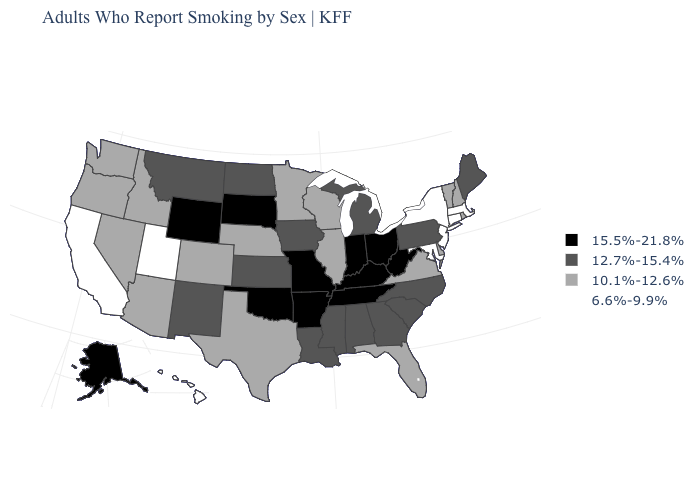Among the states that border Delaware , which have the lowest value?
Give a very brief answer. Maryland, New Jersey. What is the value of New York?
Quick response, please. 6.6%-9.9%. Among the states that border Tennessee , which have the lowest value?
Give a very brief answer. Virginia. Among the states that border South Dakota , which have the highest value?
Be succinct. Wyoming. Among the states that border Minnesota , does South Dakota have the highest value?
Keep it brief. Yes. What is the value of Oregon?
Keep it brief. 10.1%-12.6%. What is the lowest value in states that border New Jersey?
Be succinct. 6.6%-9.9%. Which states have the highest value in the USA?
Concise answer only. Alaska, Arkansas, Indiana, Kentucky, Missouri, Ohio, Oklahoma, South Dakota, Tennessee, West Virginia, Wyoming. Name the states that have a value in the range 10.1%-12.6%?
Short answer required. Arizona, Colorado, Delaware, Florida, Idaho, Illinois, Minnesota, Nebraska, Nevada, New Hampshire, Oregon, Rhode Island, Texas, Vermont, Virginia, Washington, Wisconsin. Name the states that have a value in the range 10.1%-12.6%?
Give a very brief answer. Arizona, Colorado, Delaware, Florida, Idaho, Illinois, Minnesota, Nebraska, Nevada, New Hampshire, Oregon, Rhode Island, Texas, Vermont, Virginia, Washington, Wisconsin. What is the value of West Virginia?
Quick response, please. 15.5%-21.8%. What is the value of Indiana?
Be succinct. 15.5%-21.8%. Does New York have the lowest value in the USA?
Quick response, please. Yes. Does the first symbol in the legend represent the smallest category?
Answer briefly. No. 